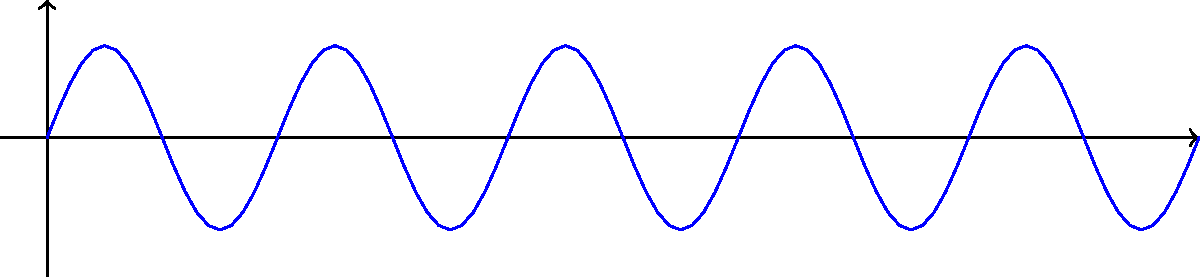In a sound wave propagation case, you're presented with evidence of a signal's characteristics. The schematic shows a wave with amplitude A = 2m, wavelength λ = 5m, and frequency f = 2 Hz. Given that the speed of sound (v) is related to frequency (f) and wavelength (λ) by the equation v = f * λ, what is the speed of this sound wave in m/s? To solve this problem, we'll use the given information and the wave equation:

1. Given:
   - Amplitude (A) = 2m (not needed for this calculation)
   - Wavelength (λ) = 5m
   - Frequency (f) = 2 Hz

2. The wave equation: 
   $v = f * \lambda$

3. Substituting the known values:
   $v = 2 \text{ Hz} * 5 \text{ m}$

4. Calculating:
   $v = 10 \text{ m/s}$

5. The units work out correctly:
   $\text{Hz} * \text{m} = \frac{1}{\text{s}} * \text{m} = \frac{\text{m}}{\text{s}}$

Therefore, the speed of the sound wave is 10 m/s.
Answer: 10 m/s 